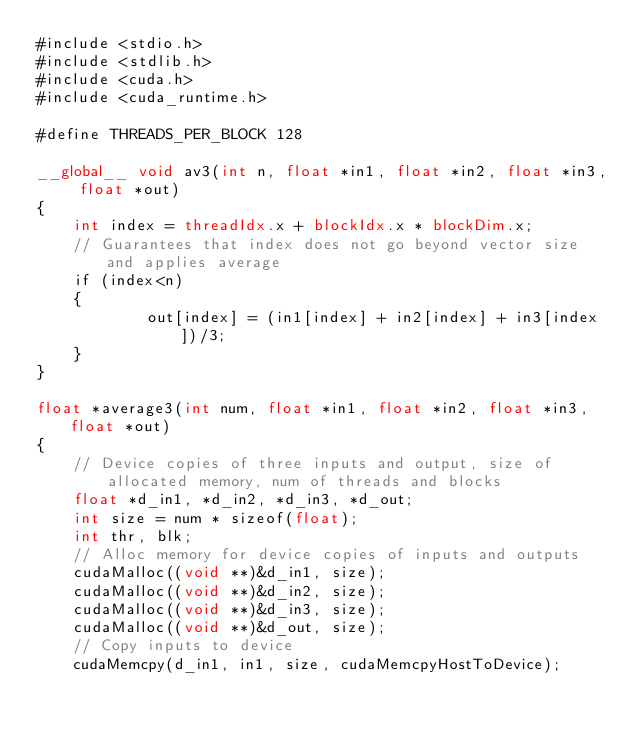<code> <loc_0><loc_0><loc_500><loc_500><_Cuda_>#include <stdio.h>
#include <stdlib.h>
#include <cuda.h>
#include <cuda_runtime.h>

#define THREADS_PER_BLOCK 128

__global__ void av3(int n, float *in1, float *in2, float *in3, float *out)
{
	int index = threadIdx.x + blockIdx.x * blockDim.x;
	// Guarantees that index does not go beyond vector size and applies average
	if (index<n)
	{
			out[index] = (in1[index] + in2[index] + in3[index])/3;
	}
}

float *average3(int num, float *in1, float *in2, float *in3, float *out) 
{
	// Device copies of three inputs and output, size of allocated memory, num of threads and blocks
	float *d_in1, *d_in2, *d_in3, *d_out; 
	int size = num * sizeof(float);
	int thr, blk;
	// Alloc memory for device copies of inputs and outputs
	cudaMalloc((void **)&d_in1, size);
	cudaMalloc((void **)&d_in2, size);
	cudaMalloc((void **)&d_in3, size);
	cudaMalloc((void **)&d_out, size);
	// Copy inputs to device
	cudaMemcpy(d_in1, in1, size, cudaMemcpyHostToDevice);</code> 